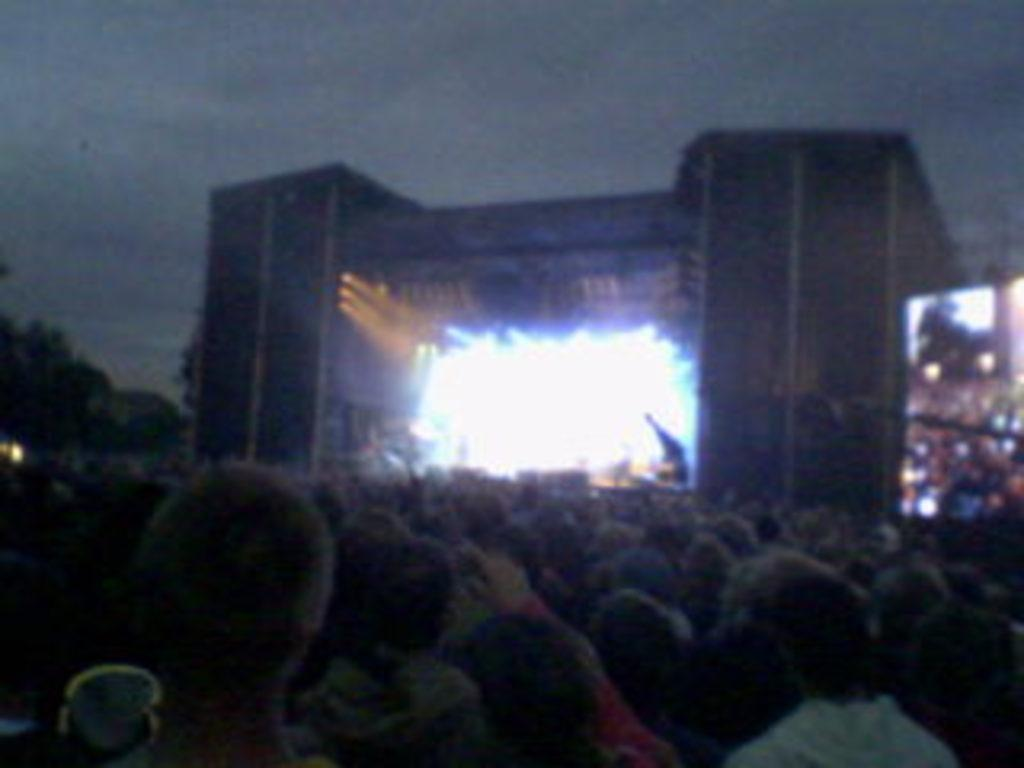How many people are visible at the bottom side of the image? There are many people at the bottom side of the image. What is located in the center of the image? There is a stage and lights in the center of the image. What is on the right side of the image? There is a screen on the right side of the image. What type of picture is hanging on the left side of the image? There is no picture mentioned in the provided facts, so we cannot answer this question. What is the zinc content of the stage in the image? There is no information about the zinc content of the stage in the image, so we cannot answer this question. 